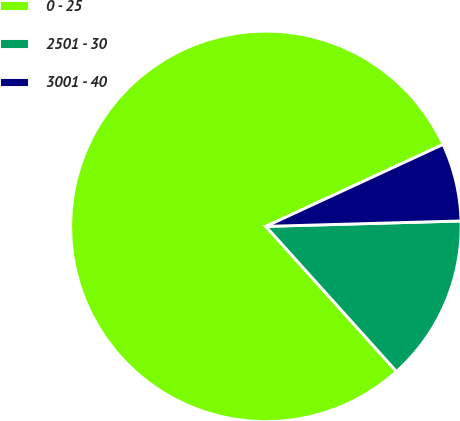Convert chart to OTSL. <chart><loc_0><loc_0><loc_500><loc_500><pie_chart><fcel>0 - 25<fcel>2501 - 30<fcel>3001 - 40<nl><fcel>79.77%<fcel>13.78%<fcel>6.45%<nl></chart> 